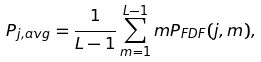<formula> <loc_0><loc_0><loc_500><loc_500>P _ { j , a v g } = \frac { 1 } { L - 1 } \sum _ { m = 1 } ^ { L - 1 } m P _ { F D F } ( j , m ) ,</formula> 